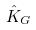<formula> <loc_0><loc_0><loc_500><loc_500>\hat { K } _ { G }</formula> 